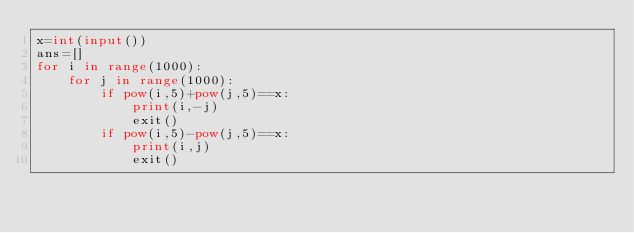<code> <loc_0><loc_0><loc_500><loc_500><_Python_>x=int(input())
ans=[]
for i in range(1000):
    for j in range(1000):
        if pow(i,5)+pow(j,5)==x:
            print(i,-j)
            exit()
        if pow(i,5)-pow(j,5)==x:
            print(i,j)
            exit()</code> 